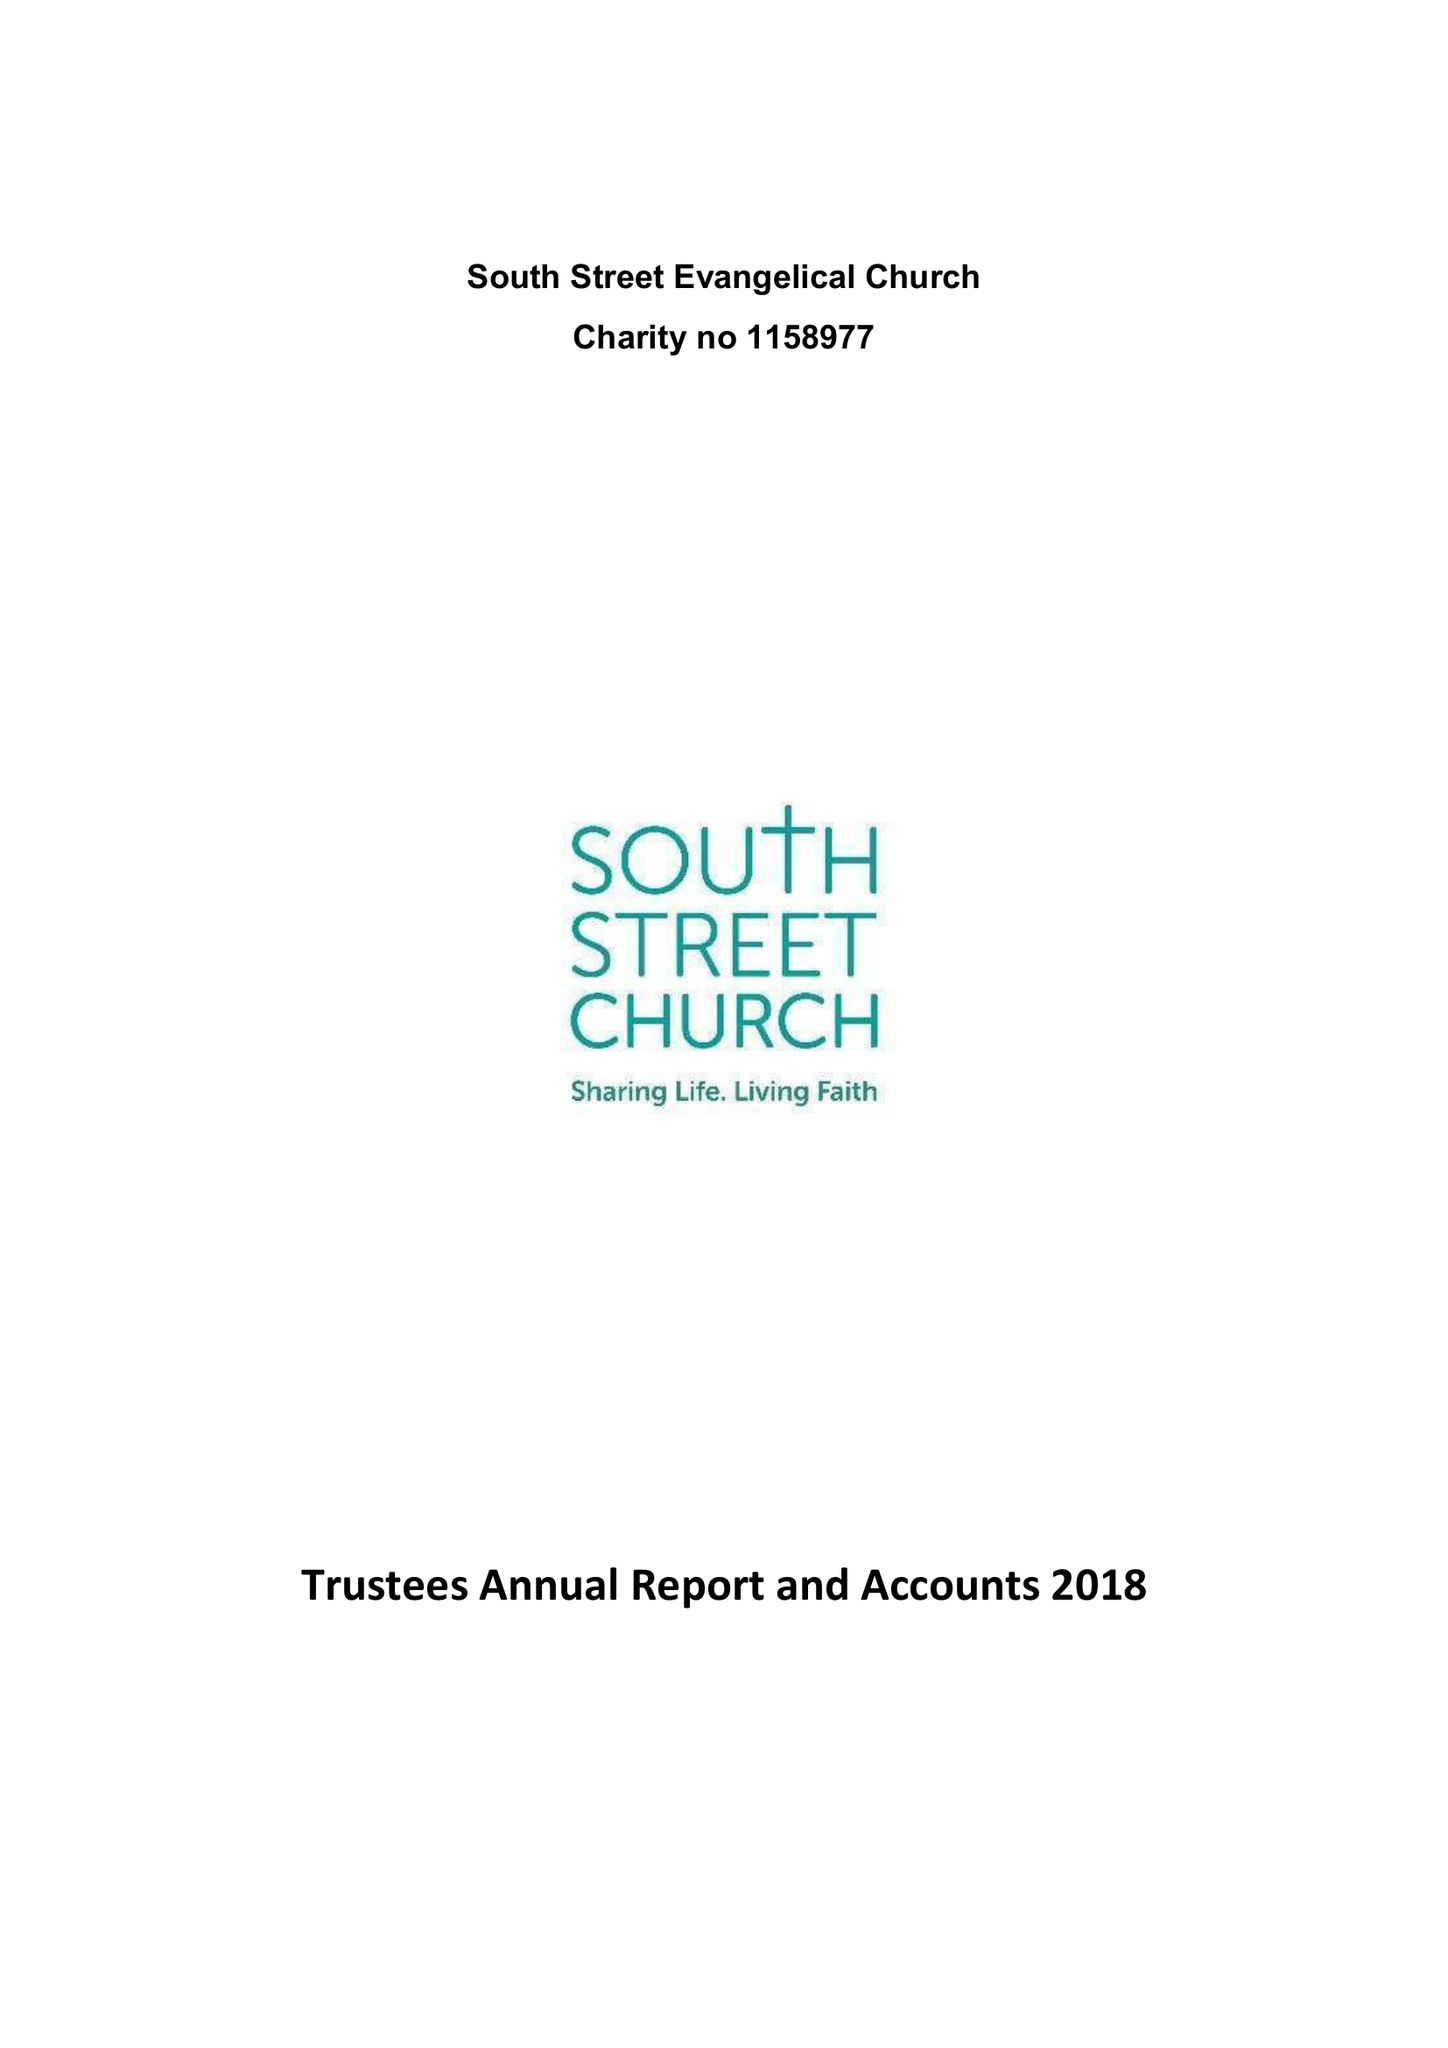What is the value for the spending_annually_in_british_pounds?
Answer the question using a single word or phrase. 100728.00 